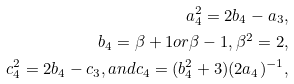Convert formula to latex. <formula><loc_0><loc_0><loc_500><loc_500>a _ { 4 } ^ { 2 } = 2 b _ { 4 } - a _ { 3 } , \\ b _ { 4 } = \beta + 1 o r \beta - 1 , \beta ^ { 2 } = 2 , \\ c _ { 4 } ^ { 2 } = 2 b _ { 4 } - c _ { 3 } , a n d c _ { 4 } = ( b _ { 4 } ^ { 2 } + 3 ) ( 2 a _ { 4 } ) ^ { - 1 } ,</formula> 